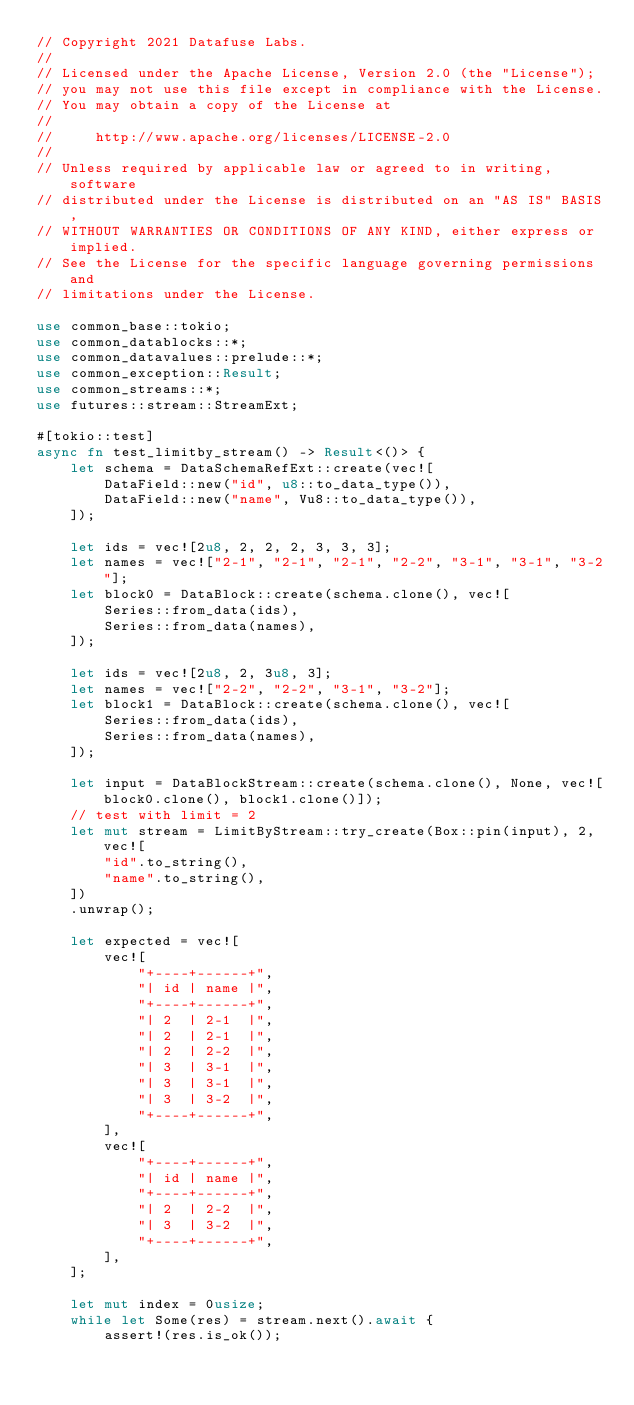<code> <loc_0><loc_0><loc_500><loc_500><_Rust_>// Copyright 2021 Datafuse Labs.
//
// Licensed under the Apache License, Version 2.0 (the "License");
// you may not use this file except in compliance with the License.
// You may obtain a copy of the License at
//
//     http://www.apache.org/licenses/LICENSE-2.0
//
// Unless required by applicable law or agreed to in writing, software
// distributed under the License is distributed on an "AS IS" BASIS,
// WITHOUT WARRANTIES OR CONDITIONS OF ANY KIND, either express or implied.
// See the License for the specific language governing permissions and
// limitations under the License.

use common_base::tokio;
use common_datablocks::*;
use common_datavalues::prelude::*;
use common_exception::Result;
use common_streams::*;
use futures::stream::StreamExt;

#[tokio::test]
async fn test_limitby_stream() -> Result<()> {
    let schema = DataSchemaRefExt::create(vec![
        DataField::new("id", u8::to_data_type()),
        DataField::new("name", Vu8::to_data_type()),
    ]);

    let ids = vec![2u8, 2, 2, 2, 3, 3, 3];
    let names = vec!["2-1", "2-1", "2-1", "2-2", "3-1", "3-1", "3-2"];
    let block0 = DataBlock::create(schema.clone(), vec![
        Series::from_data(ids),
        Series::from_data(names),
    ]);

    let ids = vec![2u8, 2, 3u8, 3];
    let names = vec!["2-2", "2-2", "3-1", "3-2"];
    let block1 = DataBlock::create(schema.clone(), vec![
        Series::from_data(ids),
        Series::from_data(names),
    ]);

    let input = DataBlockStream::create(schema.clone(), None, vec![block0.clone(), block1.clone()]);
    // test with limit = 2
    let mut stream = LimitByStream::try_create(Box::pin(input), 2, vec![
        "id".to_string(),
        "name".to_string(),
    ])
    .unwrap();

    let expected = vec![
        vec![
            "+----+------+",
            "| id | name |",
            "+----+------+",
            "| 2  | 2-1  |",
            "| 2  | 2-1  |",
            "| 2  | 2-2  |",
            "| 3  | 3-1  |",
            "| 3  | 3-1  |",
            "| 3  | 3-2  |",
            "+----+------+",
        ],
        vec![
            "+----+------+",
            "| id | name |",
            "+----+------+",
            "| 2  | 2-2  |",
            "| 3  | 3-2  |",
            "+----+------+",
        ],
    ];

    let mut index = 0usize;
    while let Some(res) = stream.next().await {
        assert!(res.is_ok());</code> 